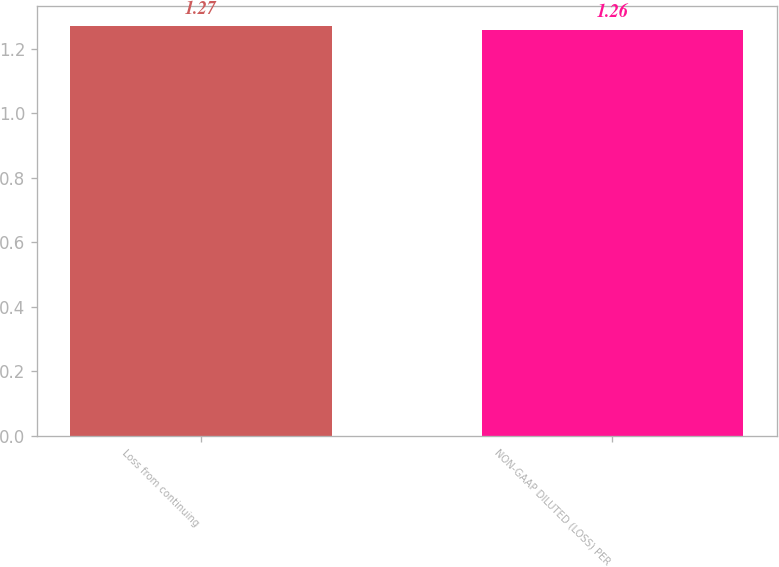Convert chart. <chart><loc_0><loc_0><loc_500><loc_500><bar_chart><fcel>Loss from continuing<fcel>NON-GAAP DILUTED (LOSS) PER<nl><fcel>1.27<fcel>1.26<nl></chart> 